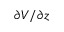Convert formula to latex. <formula><loc_0><loc_0><loc_500><loc_500>\partial V / \partial z</formula> 